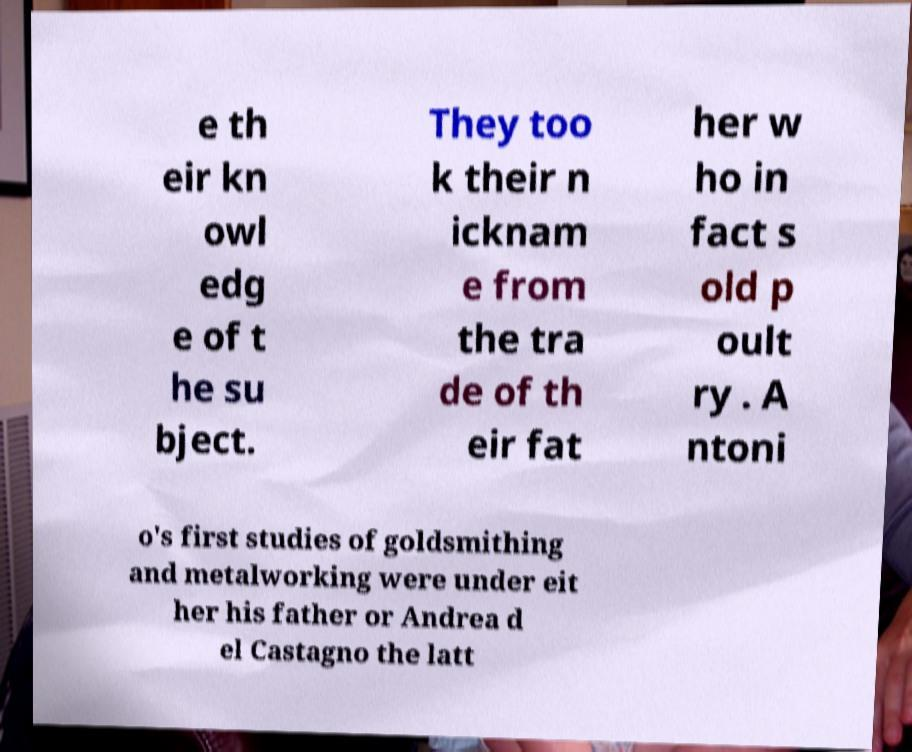Could you extract and type out the text from this image? e th eir kn owl edg e of t he su bject. They too k their n icknam e from the tra de of th eir fat her w ho in fact s old p oult ry . A ntoni o's first studies of goldsmithing and metalworking were under eit her his father or Andrea d el Castagno the latt 